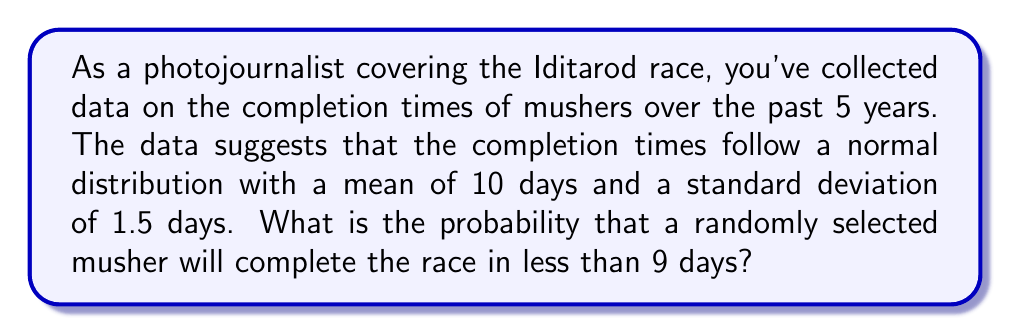Can you solve this math problem? To solve this problem, we need to use the properties of the normal distribution and the concept of z-scores.

Step 1: Identify the given information
- The completion times follow a normal distribution
- Mean (μ) = 10 days
- Standard deviation (σ) = 1.5 days
- We want to find P(X < 9), where X is the completion time

Step 2: Calculate the z-score for 9 days
The z-score formula is: $z = \frac{x - μ}{σ}$
$$z = \frac{9 - 10}{1.5} = -\frac{1}{1.5} = -0.6667$$

Step 3: Use the standard normal distribution table or a calculator to find the probability
We need to find P(Z < -0.6667)

Using a standard normal distribution table or calculator, we find:
P(Z < -0.6667) ≈ 0.2525

Step 4: Interpret the result
The probability that a randomly selected musher will complete the race in less than 9 days is approximately 0.2525 or 25.25%.
Answer: 0.2525 